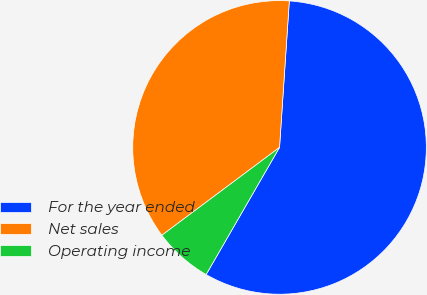<chart> <loc_0><loc_0><loc_500><loc_500><pie_chart><fcel>For the year ended<fcel>Net sales<fcel>Operating income<nl><fcel>57.27%<fcel>36.27%<fcel>6.46%<nl></chart> 